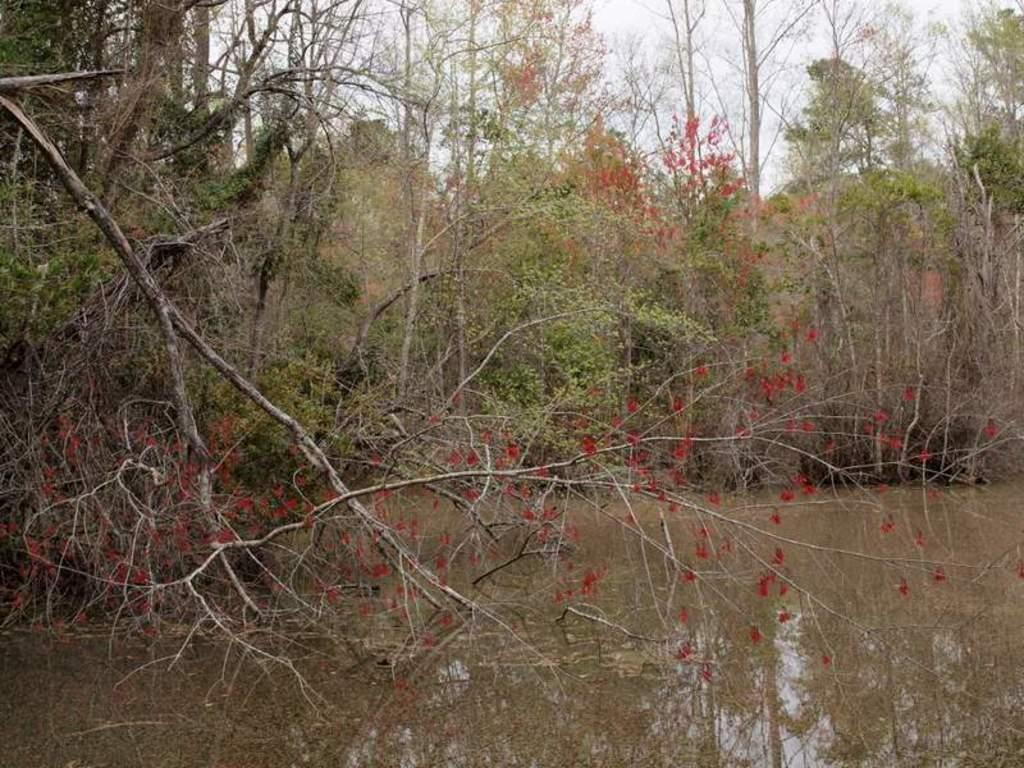What type of vegetation can be seen in the image? There are trees in the image. What natural element is visible besides the trees? There is water visible in the image. How would you describe the sky in the image? The sky appears to be cloudy in the image. What type of crack can be seen in the image? There is no crack present in the image. What animal can be seen interacting with the water in the image? There are no animals visible in the image. 